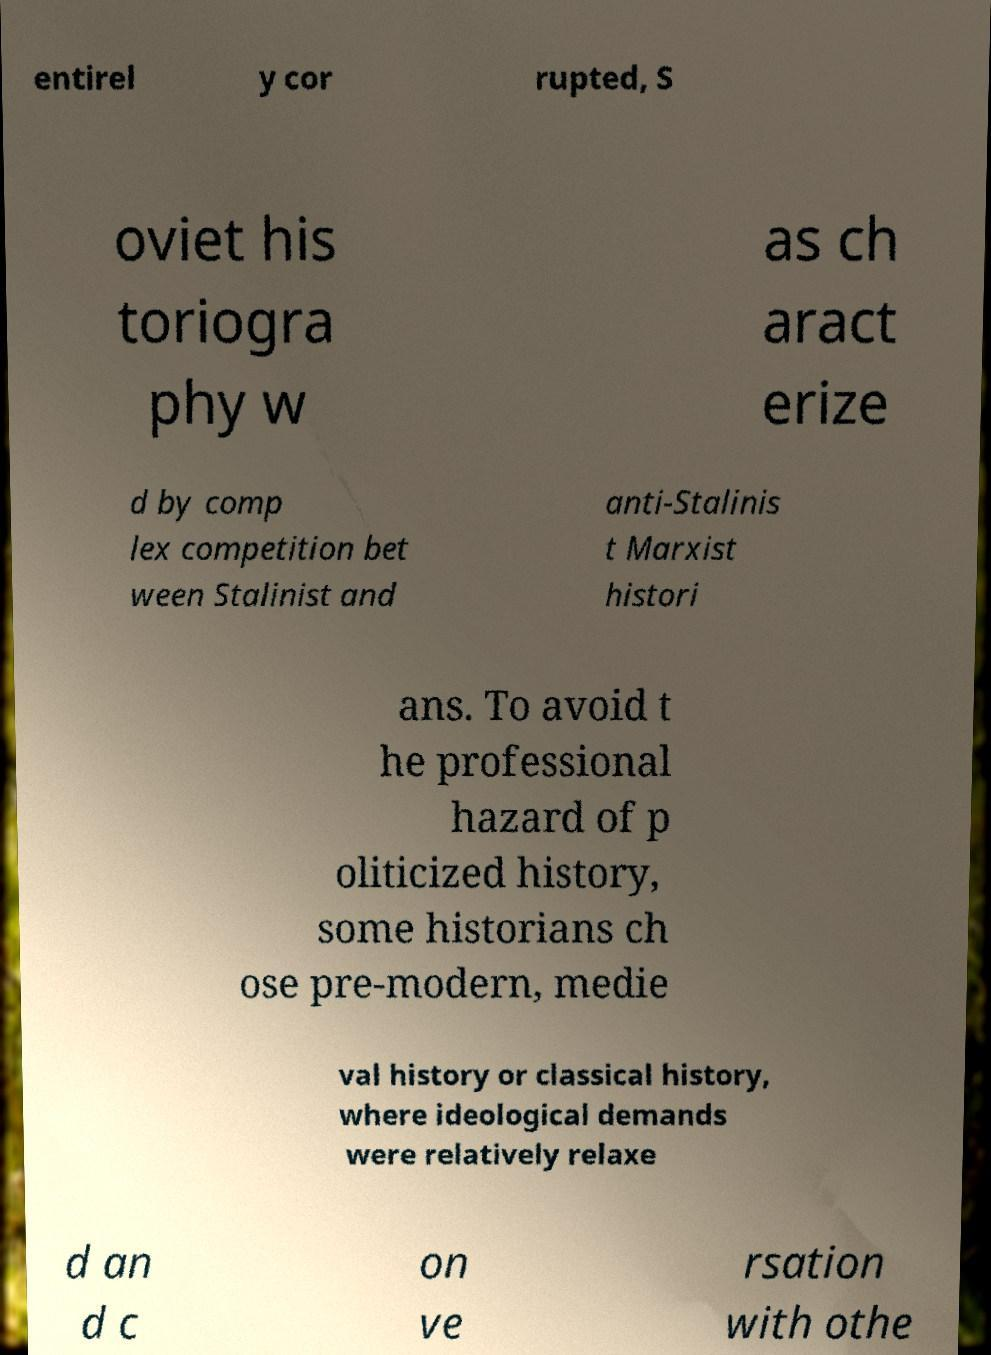Could you assist in decoding the text presented in this image and type it out clearly? entirel y cor rupted, S oviet his toriogra phy w as ch aract erize d by comp lex competition bet ween Stalinist and anti-Stalinis t Marxist histori ans. To avoid t he professional hazard of p oliticized history, some historians ch ose pre-modern, medie val history or classical history, where ideological demands were relatively relaxe d an d c on ve rsation with othe 